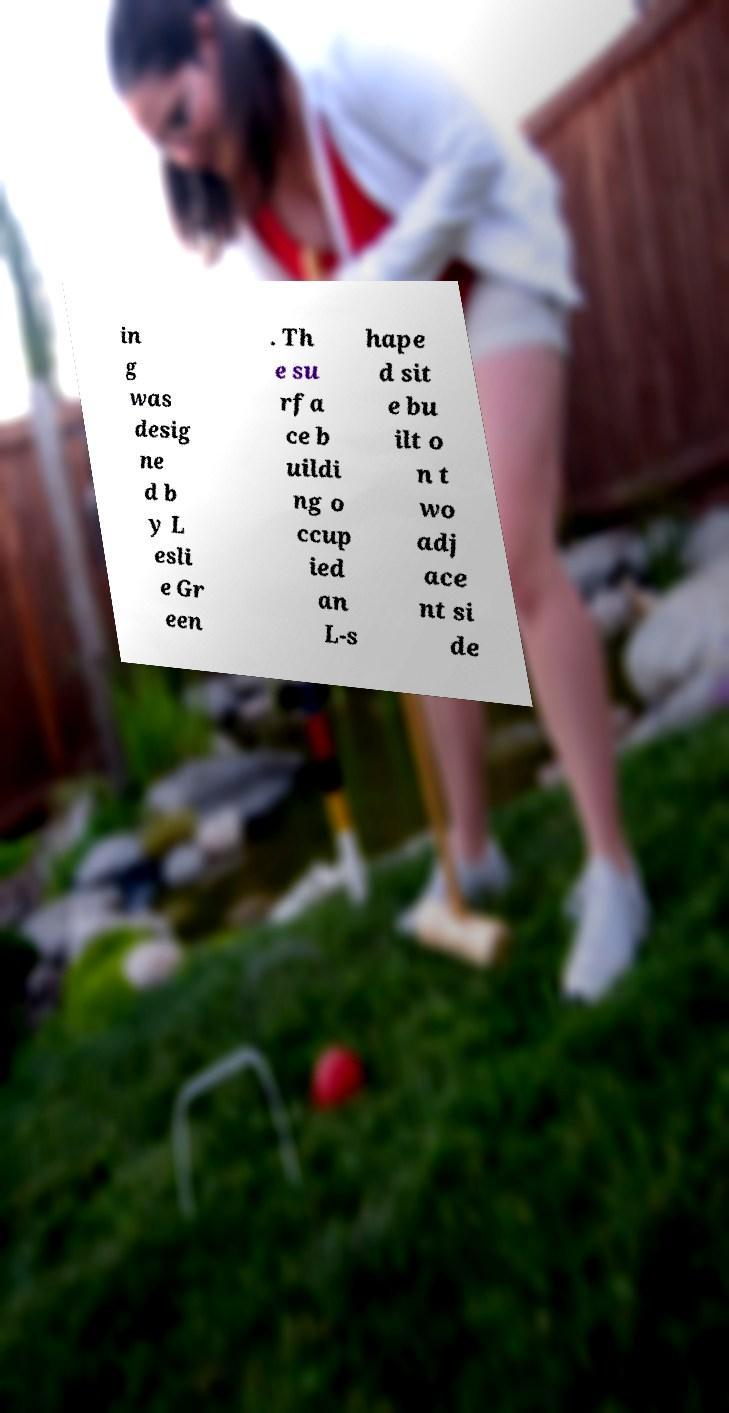For documentation purposes, I need the text within this image transcribed. Could you provide that? in g was desig ne d b y L esli e Gr een . Th e su rfa ce b uildi ng o ccup ied an L-s hape d sit e bu ilt o n t wo adj ace nt si de 